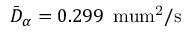<formula> <loc_0><loc_0><loc_500><loc_500>\bar { D } _ { \alpha } = 0 . 2 9 9 \, { \ m u m ^ { 2 } / s }</formula> 